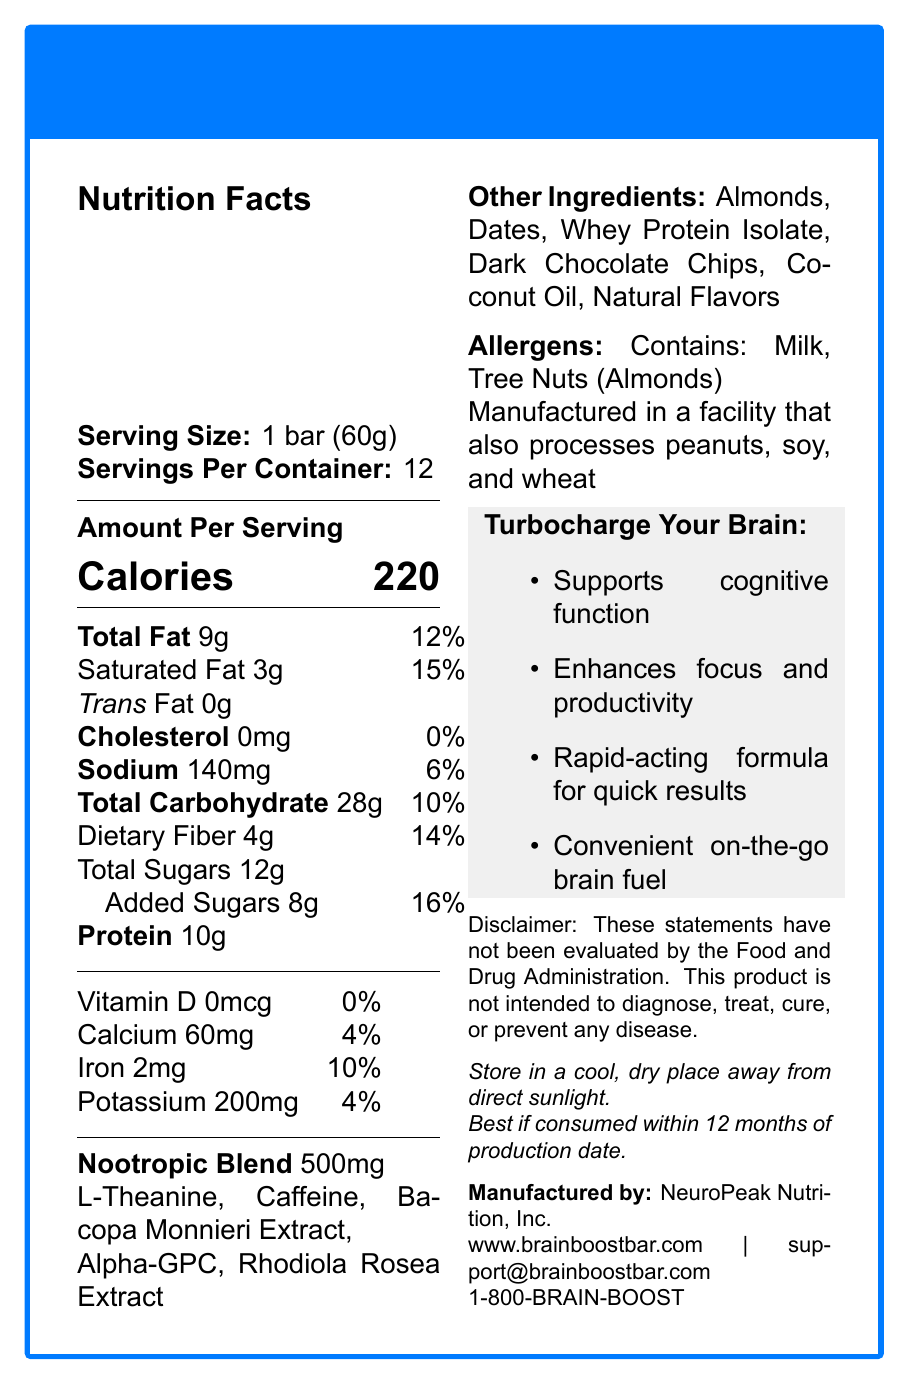what is the serving size of the BrainBoost Bar? The serving size is clearly listed as "1 bar (60g)" in the document.
Answer: 1 bar (60g) how many servings are there per container? The document specifies that there are 12 servings per container.
Answer: 12 how many grams of protein are in one serving of the BrainBoost Bar? The amount of protein per serving is listed as "10g" in the Nutrition Facts section.
Answer: 10g what is the total fat content per serving, and its daily value percentage? The total fat content per serving is 9g, which is 12% of the daily value.
Answer: 9g, 12% which ingredient is not part of the nootropic blend? A. L-Theanine B. Dark Chocolate Chips C. Bacopa Monnieri Extract D. Alpha-GPC Dark Chocolate Chips is listed under "Other Ingredients" and not part of the nootropic blend.
Answer: B what is the nootropic blend amount in one bar? The nootropic blend amount per serving is indicated as 500mg.
Answer: 500mg does the BrainBoost Bar contain any trans fat? The document mentions that the BrainBoost Bar contains 0g of trans fat.
Answer: No what allergens are present in the BrainBoost Bar? The allergens listed include "Contains: Milk, Tree Nuts (Almonds)."
Answer: Milk, Tree Nuts (Almonds) which vitamin does the BrainBoost Bar contain the least? A. Vitamin D B. Calcium C. Iron D. Potassium The BrainBoost Bar contains 0mcg of Vitamin D, which is 0% of the daily value, making it the least present vitamin.
Answer: A what is the main idea of this document? The document is organized to provide nutritional information, ingredients, allergen warnings, and company details for the BrainBoost Bar, which is marketed as a cognitive performance booster.
Answer: The BrainBoost Bar is a nootropic-infused snack designed to boost cognitive performance. It provides details about its nutritional contents, ingredients, allergens, and marketing claims. is the BrainBoost Bar suitable for individuals with peanut allergies? The document states that the product is manufactured in a facility that also processes peanuts, indicating a possible risk of cross-contamination.
Answer: No what company manufactures the BrainBoost Bar? The manufacturer is listed as NeuroPeak Nutrition, Inc.
Answer: NeuroPeak Nutrition, Inc. what are the marketing claims made for the BrainBoost Bar? The marketing claims listed in the document include enhancing cognitive function and productivity, providing quick results, and offering on-the-go brain fuel.
Answer: Supports cognitive function, enhances focus and productivity, rapid-acting formula for quick results, convenient on-the-go brain fuel how much dietary fiber is in each serving, and what is its daily value percentage? Each serving contains 4g of dietary fiber, which is 14% of the daily value.
Answer: 4g, 14% what is the expiration date for the BrainBoost Bar? The expiration details note that the bar is best if consumed within 12 months of the production date.
Answer: Best if consumed within 12 months of production date. who should be contacted for more information about the BrainBoost Bar? The contact information includes both an email address and a phone number: support@brainboostbar.com and 1-800-BRAIN-BOOST.
Answer: support@brainboostbar.com or 1-800-BRAIN-BOOST what percentage of daily value does the sodium content represent? The sodium content per serving is 140mg, representing 6% of the daily value.
Answer: 6% how much added sugar does each serving of BrainBoost Bar contain? Each serving contains 8g of added sugars, which is 16% of the daily value.
Answer: 8g, 16% where should the BrainBoost Bar be stored for best results? The document specifies storage instructions as "Store in a cool, dry place away from direct sunlight."
Answer: In a cool, dry place away from direct sunlight has the FDA evaluated the claims made about the BrainBoost Bar’s benefits? The disclaimer states that these statements have not been evaluated by the Food and Drug Administration.
Answer: No what is the total calcium content per serving, and its daily value percentage? Each serving contains 60mg of calcium, which is 4% of the daily value.
Answer: 60mg, 4% what is the primary focus of the marketing claims for the BrainBoost Bar? The marketing claims primarily focus on cognitive function support, enhanced focus and productivity, and the convenience of a rapid-acting formula for quick results.
Answer: Cognitive enhancement and convenience how many grams of total carbohydrates are there in each BrainBoost Bar? The total carbohydrates content per serving is 28g.
Answer: 28g what other types of ingredients aside from the nootropic blend are in the BrainBoost Bar? The "Other Ingredients" section lists these items.
Answer: Almonds, Dates, Whey Protein Isolate, Dark Chocolate Chips, Coconut Oil, Natural Flavors what is the iron content and its daily value percentage per serving? Each serving contains 2mg of iron, representing 10% of the daily value.
Answer: 2mg, 10% what is the amount of potassium per serving? The potassium content per serving is listed as 200mg.
Answer: 200mg has the BrainBoost Bar been clinically proven to improve cognitive performance? The document mentions marketing claims for cognitive support but includes a disclaimer stating that these claims have not been evaluated by the FDA.
Answer: Not enough information 